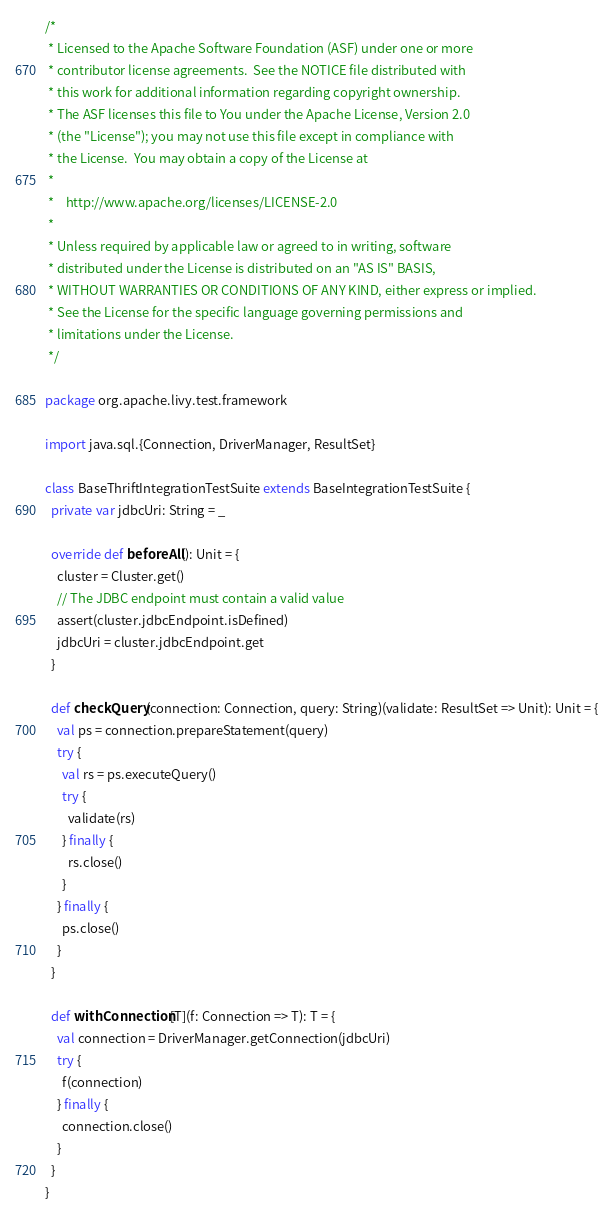<code> <loc_0><loc_0><loc_500><loc_500><_Scala_>/*
 * Licensed to the Apache Software Foundation (ASF) under one or more
 * contributor license agreements.  See the NOTICE file distributed with
 * this work for additional information regarding copyright ownership.
 * The ASF licenses this file to You under the Apache License, Version 2.0
 * (the "License"); you may not use this file except in compliance with
 * the License.  You may obtain a copy of the License at
 *
 *    http://www.apache.org/licenses/LICENSE-2.0
 *
 * Unless required by applicable law or agreed to in writing, software
 * distributed under the License is distributed on an "AS IS" BASIS,
 * WITHOUT WARRANTIES OR CONDITIONS OF ANY KIND, either express or implied.
 * See the License for the specific language governing permissions and
 * limitations under the License.
 */

package org.apache.livy.test.framework

import java.sql.{Connection, DriverManager, ResultSet}

class BaseThriftIntegrationTestSuite extends BaseIntegrationTestSuite {
  private var jdbcUri: String = _

  override def beforeAll(): Unit = {
    cluster = Cluster.get()
    // The JDBC endpoint must contain a valid value
    assert(cluster.jdbcEndpoint.isDefined)
    jdbcUri = cluster.jdbcEndpoint.get
  }

  def checkQuery(connection: Connection, query: String)(validate: ResultSet => Unit): Unit = {
    val ps = connection.prepareStatement(query)
    try {
      val rs = ps.executeQuery()
      try {
        validate(rs)
      } finally {
        rs.close()
      }
    } finally {
      ps.close()
    }
  }

  def withConnection[T](f: Connection => T): T = {
    val connection = DriverManager.getConnection(jdbcUri)
    try {
      f(connection)
    } finally {
      connection.close()
    }
  }
}
</code> 